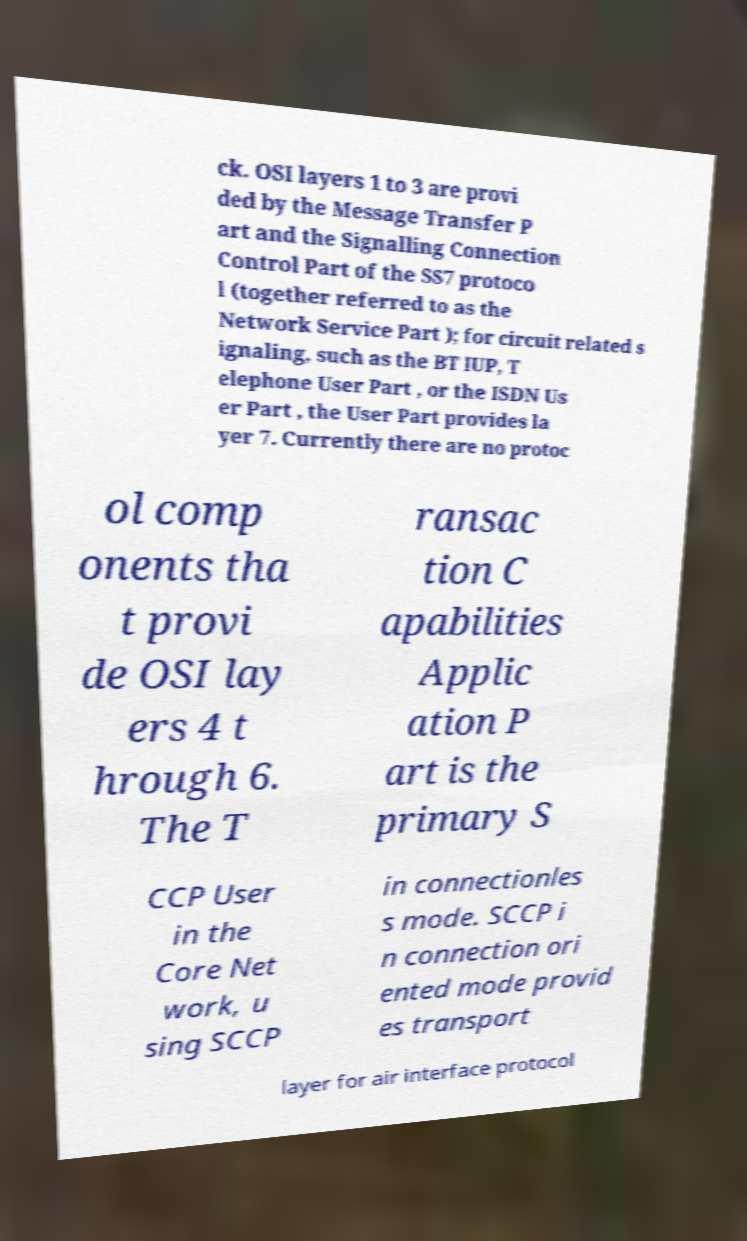Can you accurately transcribe the text from the provided image for me? ck. OSI layers 1 to 3 are provi ded by the Message Transfer P art and the Signalling Connection Control Part of the SS7 protoco l (together referred to as the Network Service Part ); for circuit related s ignaling, such as the BT IUP, T elephone User Part , or the ISDN Us er Part , the User Part provides la yer 7. Currently there are no protoc ol comp onents tha t provi de OSI lay ers 4 t hrough 6. The T ransac tion C apabilities Applic ation P art is the primary S CCP User in the Core Net work, u sing SCCP in connectionles s mode. SCCP i n connection ori ented mode provid es transport layer for air interface protocol 